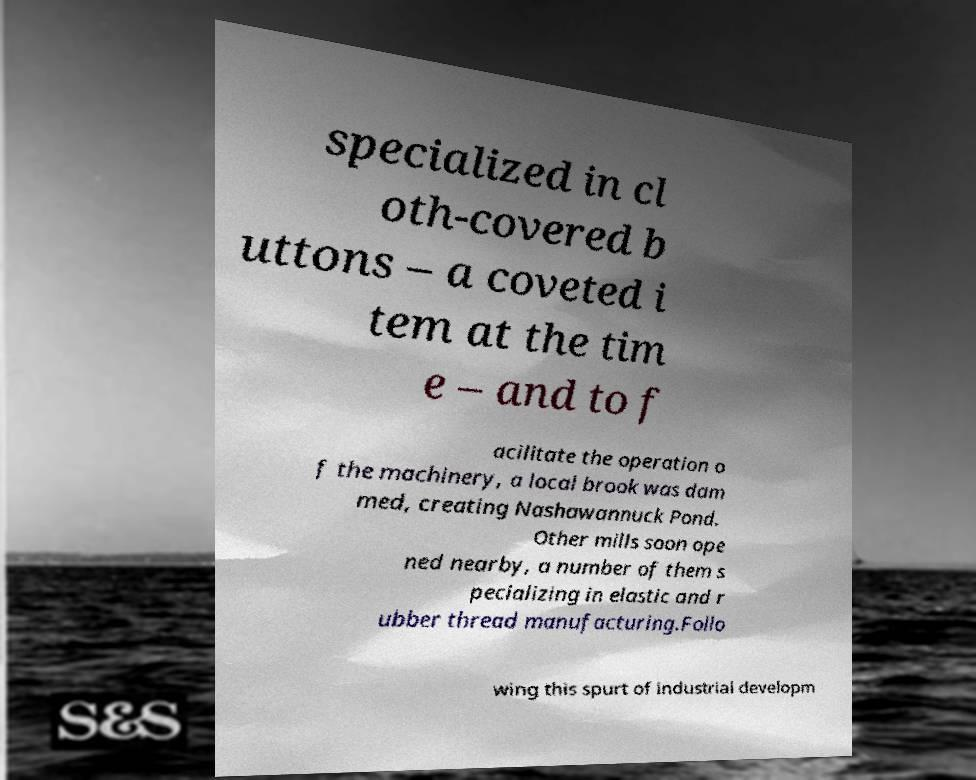For documentation purposes, I need the text within this image transcribed. Could you provide that? specialized in cl oth-covered b uttons – a coveted i tem at the tim e – and to f acilitate the operation o f the machinery, a local brook was dam med, creating Nashawannuck Pond. Other mills soon ope ned nearby, a number of them s pecializing in elastic and r ubber thread manufacturing.Follo wing this spurt of industrial developm 